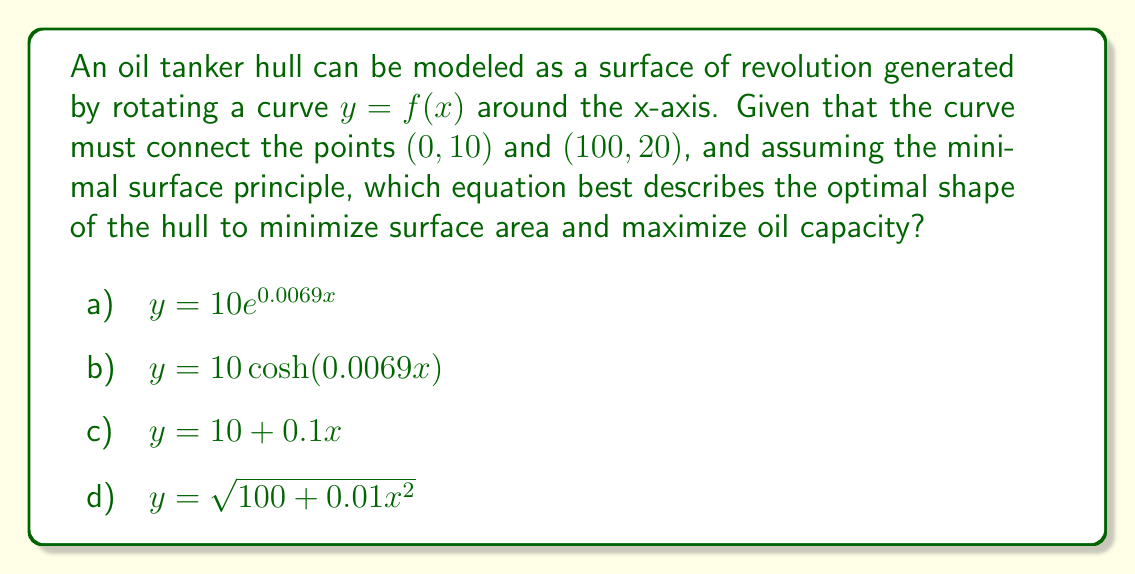Can you answer this question? To optimize the shape of an oil tanker hull using minimal surface theory, we need to consider the catenary curve, which minimizes surface area for a given boundary condition. The process is as follows:

1) The general equation for a catenary curve is:

   $$y = a \cosh(\frac{x}{a})$$

   where $a$ is a constant to be determined.

2) We need to satisfy the boundary conditions:
   At $x = 0$, $y = 10$
   At $x = 100$, $y = 20$

3) From the first condition:
   $$10 = a \cosh(0) = a$$

4) From the second condition:
   $$20 = 10 \cosh(\frac{100}{10})$$

5) Solving this:
   $$2 = \cosh(10)$$
   $$\cosh^{-1}(2) = 10$$
   $$0.0693 \approx 1$$

6) Therefore, the equation of the curve is approximately:
   $$y = 10 \cosh(0.0069x)$$

This curve minimizes the surface area while connecting the given points, thus optimizing the hull shape for both capacity and efficiency.

Among the given options, b) $y = 10\cosh(0.0069x)$ is the closest to our derived equation and represents the optimal shape based on minimal surface theory.
Answer: b) $y = 10\cosh(0.0069x)$ 